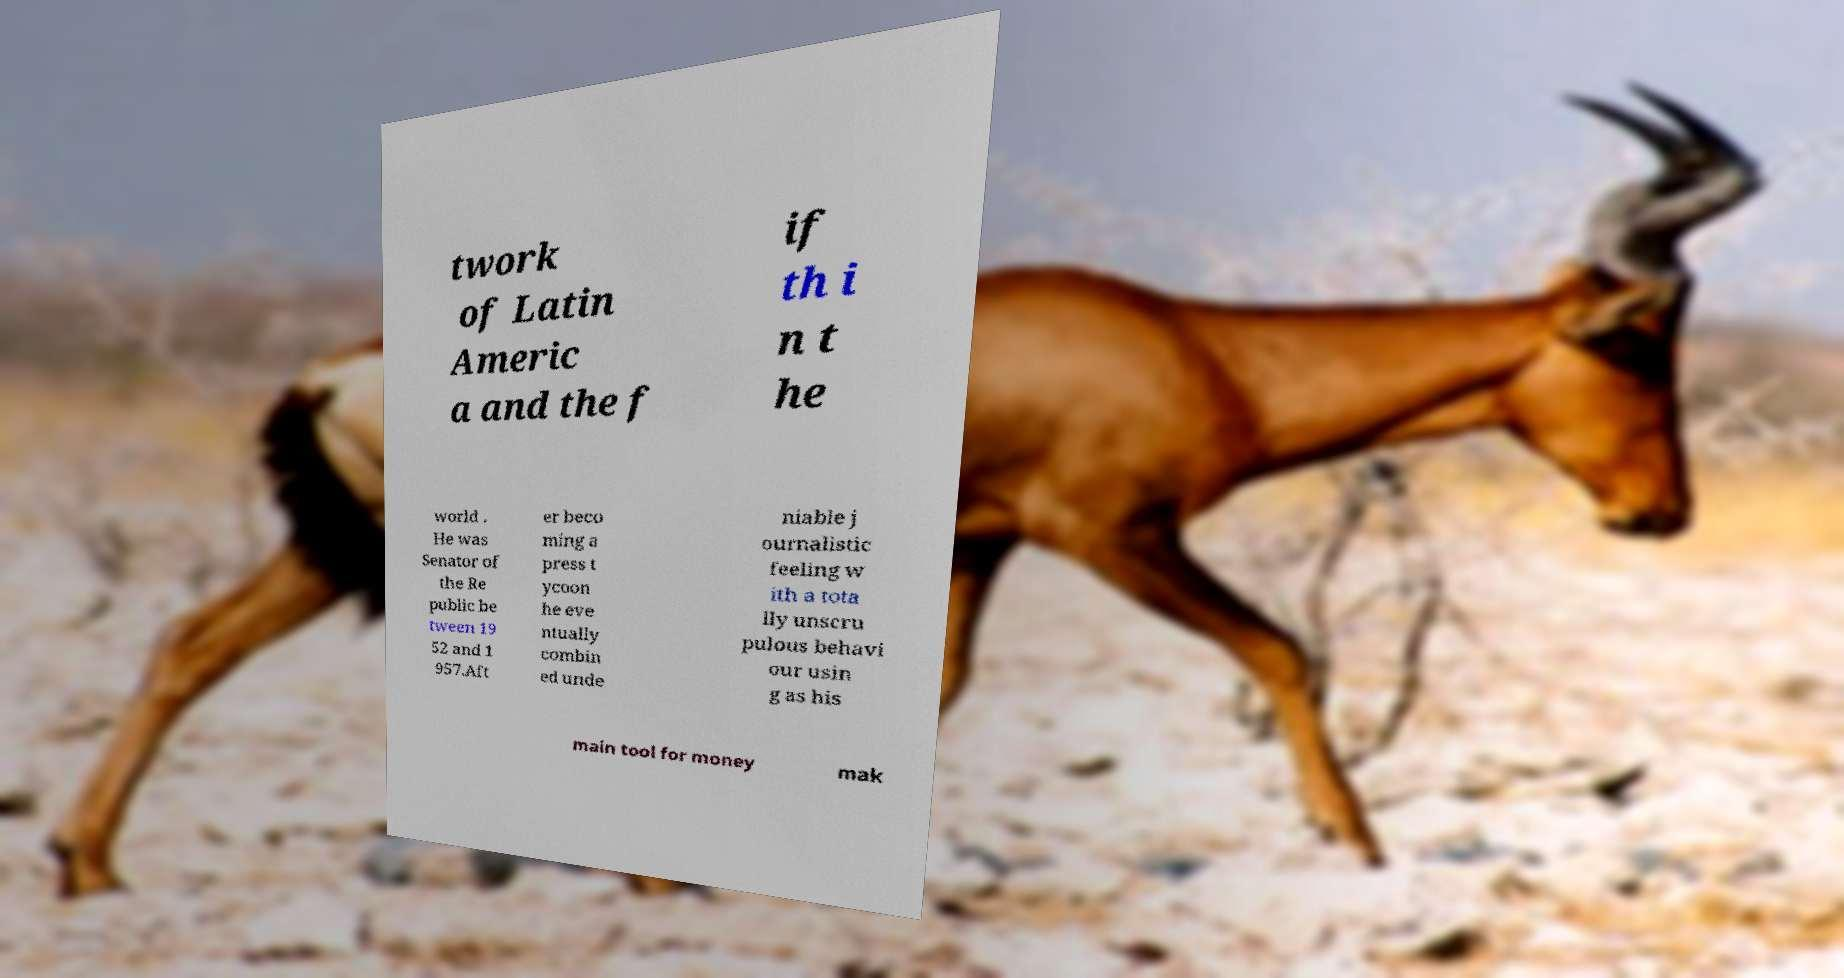For documentation purposes, I need the text within this image transcribed. Could you provide that? twork of Latin Americ a and the f if th i n t he world . He was Senator of the Re public be tween 19 52 and 1 957.Aft er beco ming a press t ycoon he eve ntually combin ed unde niable j ournalistic feeling w ith a tota lly unscru pulous behavi our usin g as his main tool for money mak 